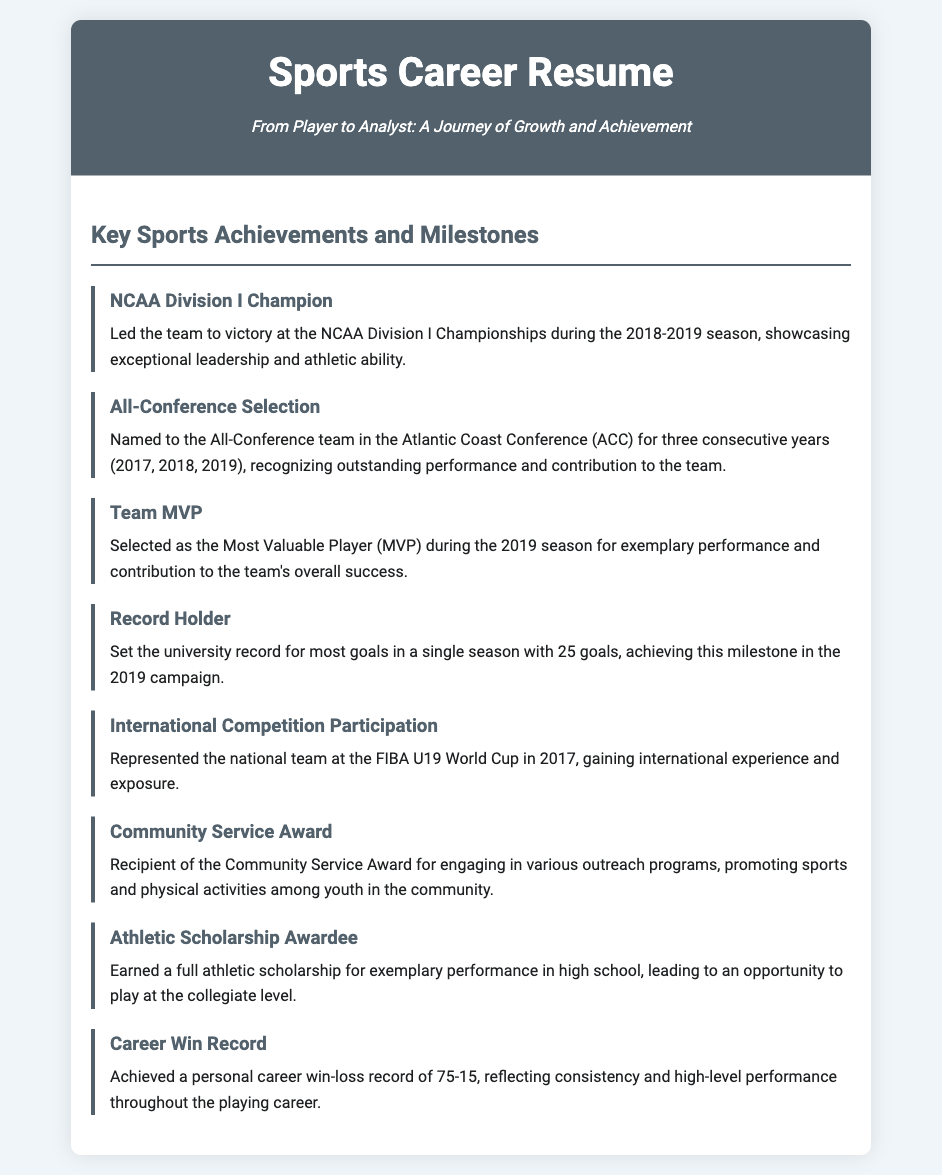What championship did the player win? The document states that the player led the team to victory at the NCAA Division I Championships.
Answer: NCAA Division I Championships In what year was the player named All-Conference for the first time? The player was named to the All-Conference team in 2017, as stated in the document.
Answer: 2017 How many goals did the player score to set the university record in a single season? The document mentions that the player set the record with 25 goals.
Answer: 25 goals What award was received for contributing to the community? The document indicates that the player received the Community Service Award.
Answer: Community Service Award How many career wins does the player have? The document outlines that the player's personal career win-loss record is 75-15, focusing on the wins.
Answer: 75 Was the player part of an international competition, and if so, which event? The document notes the player's participation in the FIBA U19 World Cup, which shows international experience.
Answer: FIBA U19 World Cup How many years did the player receive All-Conference selection? The document states that the player was named to the All-Conference team for three consecutive years.
Answer: Three years What is significant about the athletic scholarship in the player's career? The document states that the player earned a full athletic scholarship for exemplary performance in high school.
Answer: Full athletic scholarship 